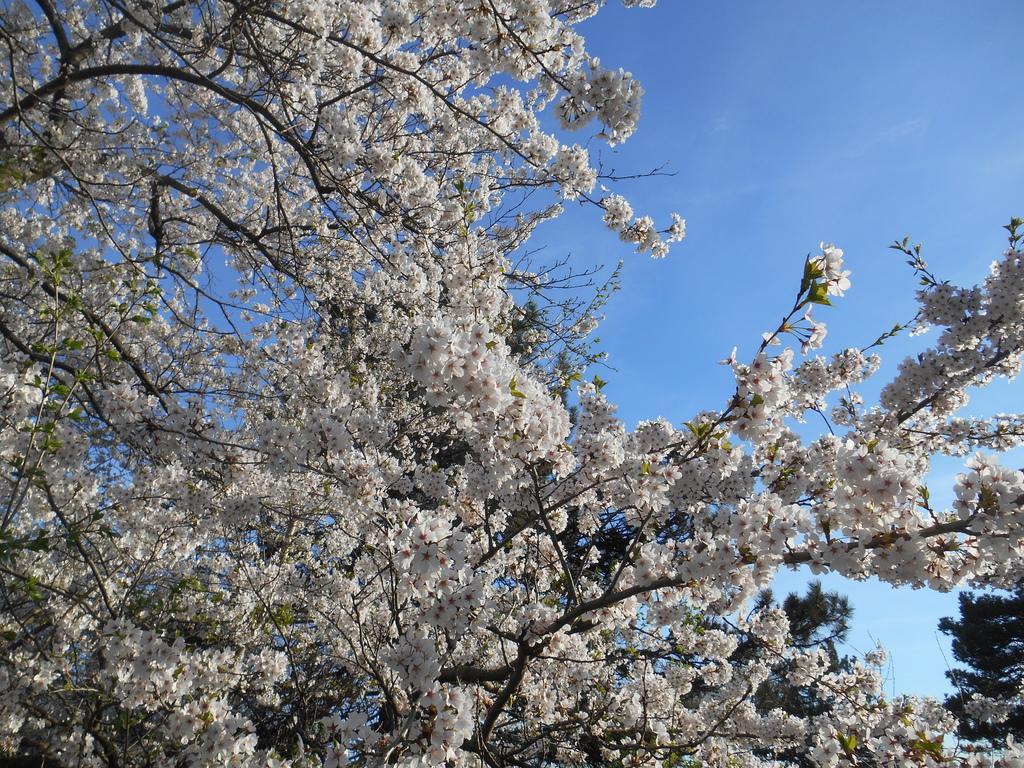How would you summarize this image in a sentence or two? There are some trees with white color flowers as we can see in the middle of this image and there is a sky in the background. 